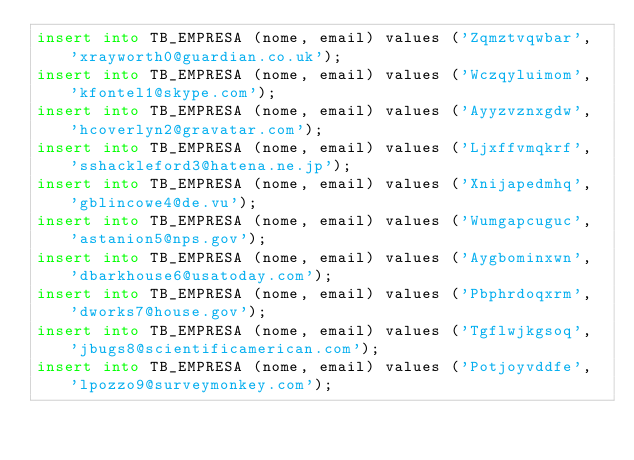<code> <loc_0><loc_0><loc_500><loc_500><_SQL_>insert into TB_EMPRESA (nome, email) values ('Zqmztvqwbar', 'xrayworth0@guardian.co.uk');
insert into TB_EMPRESA (nome, email) values ('Wczqyluimom', 'kfontel1@skype.com');
insert into TB_EMPRESA (nome, email) values ('Ayyzvznxgdw', 'hcoverlyn2@gravatar.com');
insert into TB_EMPRESA (nome, email) values ('Ljxffvmqkrf', 'sshackleford3@hatena.ne.jp');
insert into TB_EMPRESA (nome, email) values ('Xnijapedmhq', 'gblincowe4@de.vu');
insert into TB_EMPRESA (nome, email) values ('Wumgapcuguc', 'astanion5@nps.gov');
insert into TB_EMPRESA (nome, email) values ('Aygbominxwn', 'dbarkhouse6@usatoday.com');
insert into TB_EMPRESA (nome, email) values ('Pbphrdoqxrm', 'dworks7@house.gov');
insert into TB_EMPRESA (nome, email) values ('Tgflwjkgsoq', 'jbugs8@scientificamerican.com');
insert into TB_EMPRESA (nome, email) values ('Potjoyvddfe', 'lpozzo9@surveymonkey.com');</code> 